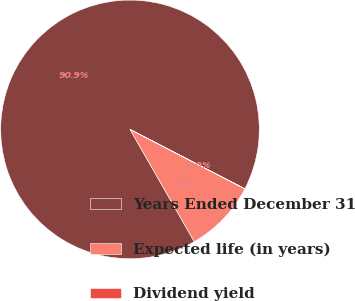<chart> <loc_0><loc_0><loc_500><loc_500><pie_chart><fcel>Years Ended December 31<fcel>Expected life (in years)<fcel>Dividend yield<nl><fcel>90.88%<fcel>9.11%<fcel>0.02%<nl></chart> 